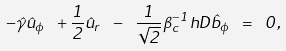Convert formula to latex. <formula><loc_0><loc_0><loc_500><loc_500>- \hat { \gamma } \hat { u } _ { \phi } \ + \frac { 1 } { 2 } \hat { u } _ { r } \ - \ \frac { 1 } { \sqrt { 2 } } \beta _ { c } ^ { - 1 } h D \hat { b } _ { \phi } \ = \ 0 ,</formula> 